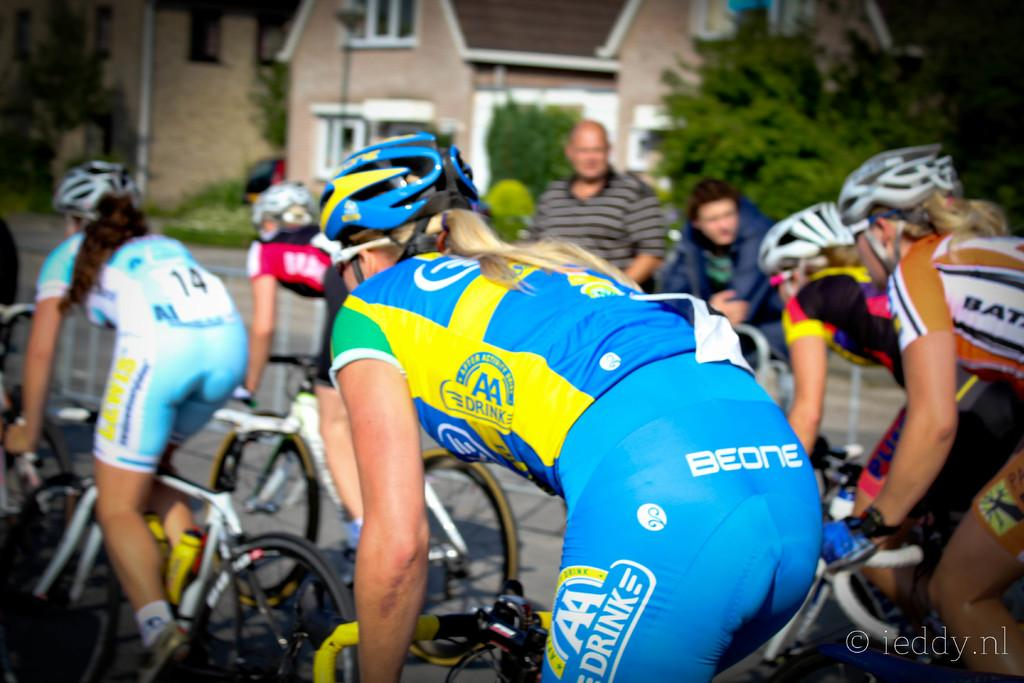What are the women in the image doing? The women in the image are riding bicycles. Are there any spectators in the image? Yes, there are two people watching the women riding bicycles. What can be seen in the background of the image? There are buildings and trees visible in the image. What type of quarter is being used to act as a soda in the image? There is no quarter or soda present in the image; it features women riding bicycles with spectators and a background of buildings and trees. 